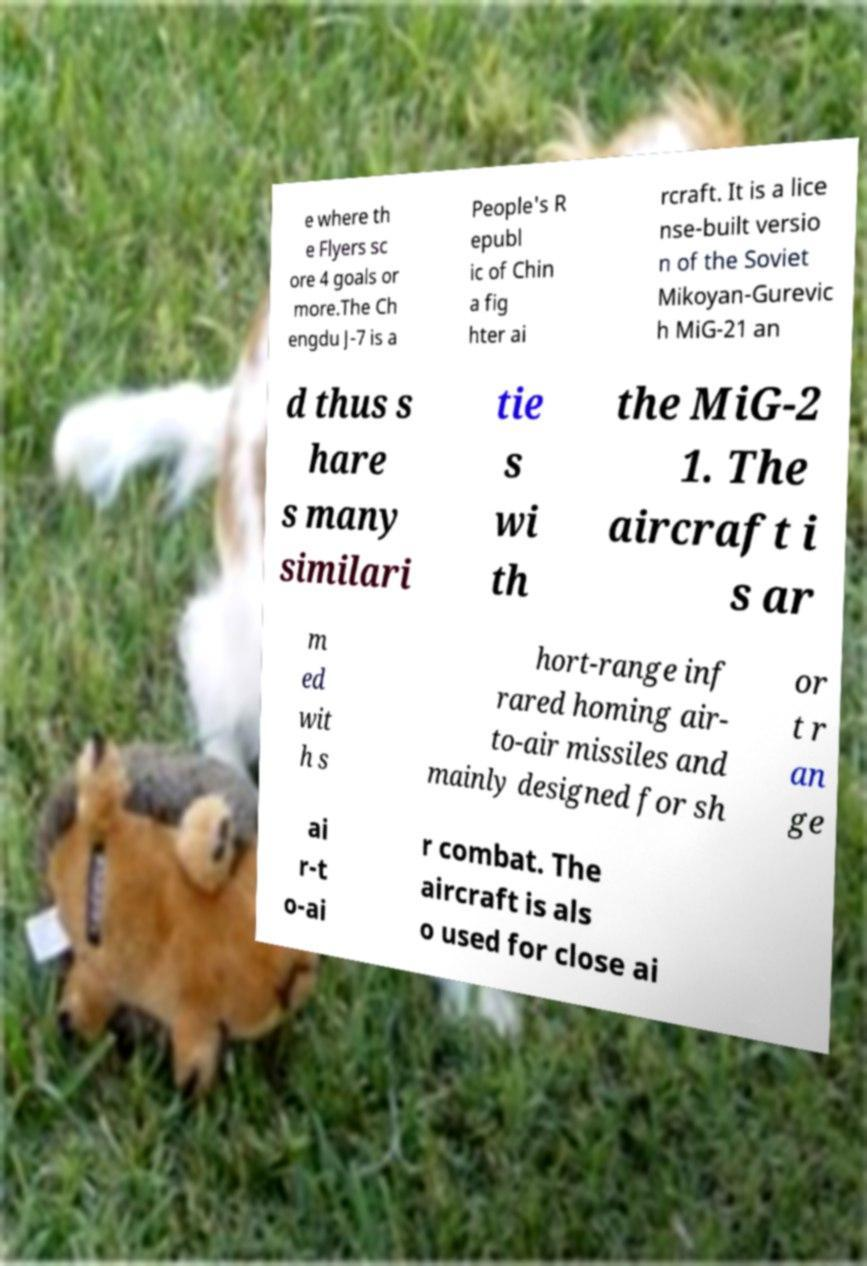What messages or text are displayed in this image? I need them in a readable, typed format. e where th e Flyers sc ore 4 goals or more.The Ch engdu J-7 is a People's R epubl ic of Chin a fig hter ai rcraft. It is a lice nse-built versio n of the Soviet Mikoyan-Gurevic h MiG-21 an d thus s hare s many similari tie s wi th the MiG-2 1. The aircraft i s ar m ed wit h s hort-range inf rared homing air- to-air missiles and mainly designed for sh or t r an ge ai r-t o-ai r combat. The aircraft is als o used for close ai 